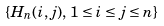<formula> <loc_0><loc_0><loc_500><loc_500>\left \{ H _ { n } ( i , j ) , \, 1 \leq i \leq j \leq n \right \}</formula> 